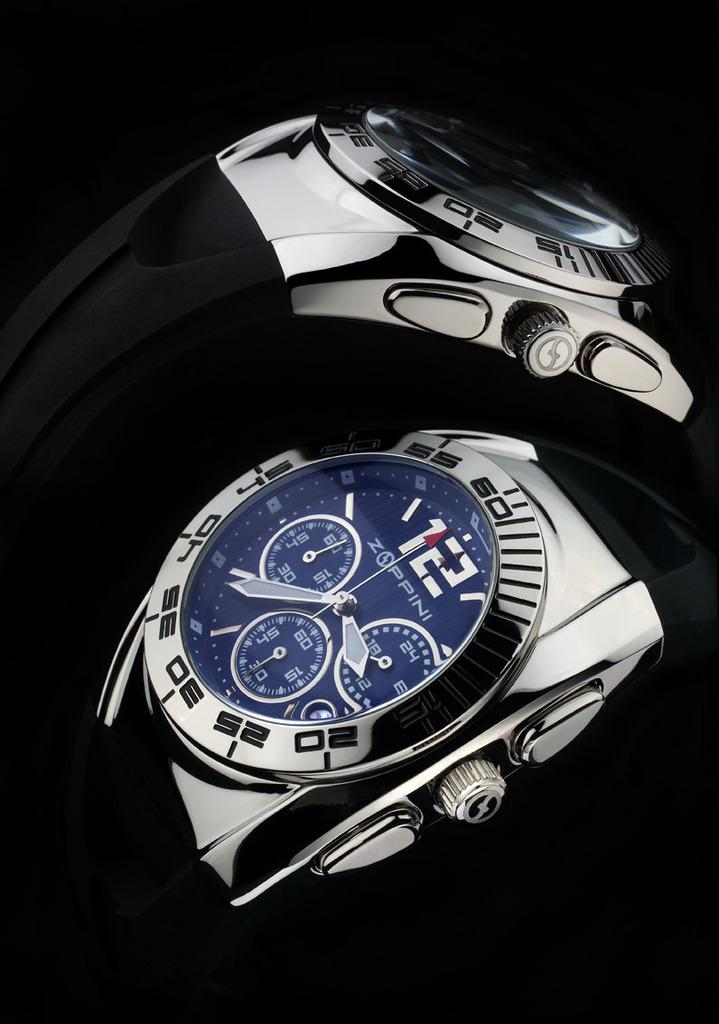<image>
Summarize the visual content of the image. A couple of shiny watches by Zoppini look expensive. 